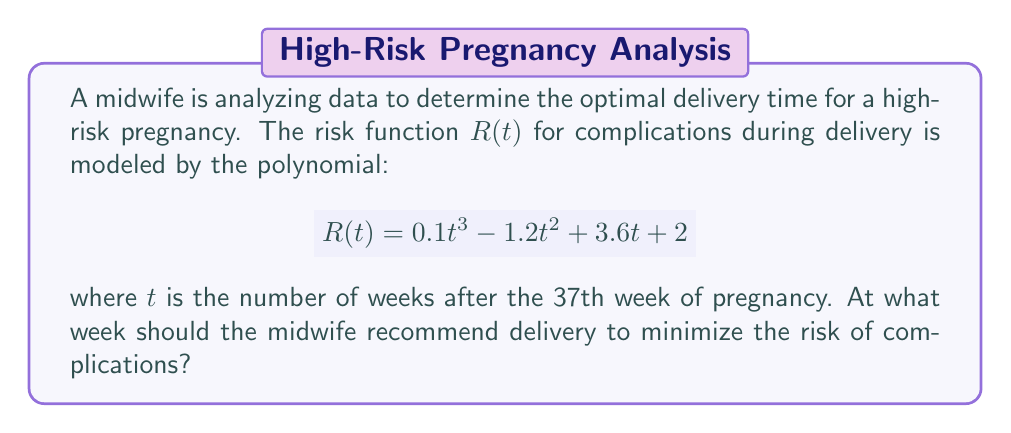Could you help me with this problem? To find the optimal delivery time, we need to determine the minimum point of the risk function $R(t)$. This can be done by following these steps:

1) First, we find the derivative of $R(t)$:
   $$R'(t) = 0.3t^2 - 2.4t + 3.6$$

2) To find the critical points, we set $R'(t) = 0$ and solve for $t$:
   $$0.3t^2 - 2.4t + 3.6 = 0$$

3) This is a quadratic equation. We can solve it using the quadratic formula:
   $$t = \frac{-b \pm \sqrt{b^2 - 4ac}}{2a}$$
   where $a = 0.3$, $b = -2.4$, and $c = 3.6$

4) Plugging in these values:
   $$t = \frac{2.4 \pm \sqrt{(-2.4)^2 - 4(0.3)(3.6)}}{2(0.3)}$$
   $$= \frac{2.4 \pm \sqrt{5.76 - 4.32}}{0.6}$$
   $$= \frac{2.4 \pm \sqrt{1.44}}{0.6}$$
   $$= \frac{2.4 \pm 1.2}{0.6}$$

5) This gives us two solutions:
   $$t_1 = \frac{2.4 + 1.2}{0.6} = 6$$
   $$t_2 = \frac{2.4 - 1.2}{0.6} = 2$$

6) To determine which of these is the minimum, we can check the second derivative:
   $$R''(t) = 0.6t - 2.4$$

7) At $t = 6$: $R''(6) = 0.6(6) - 2.4 = 1.2 > 0$, indicating a minimum.
   At $t = 2$: $R''(2) = 0.6(2) - 2.4 = -1.2 < 0$, indicating a maximum.

Therefore, the risk is minimized at $t = 6$ weeks after the 37th week of pregnancy.
Answer: The midwife should recommend delivery at 43 weeks (6 weeks after the 37th week) to minimize the risk of complications. 